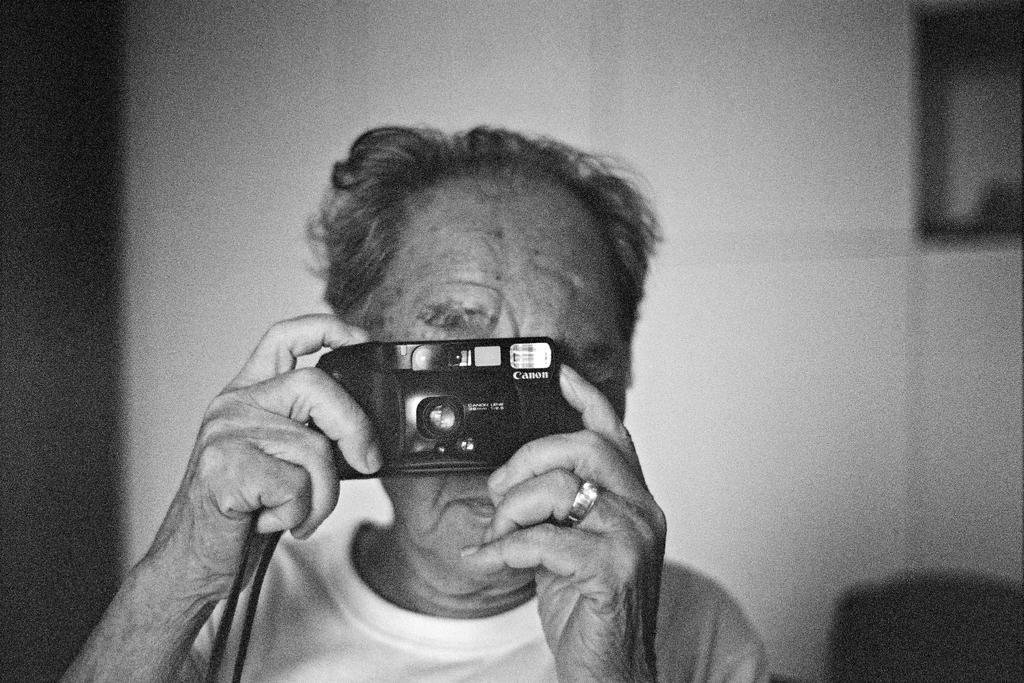In one or two sentences, can you explain what this image depicts? In the middle of the image a man is holding a camera, Behind him there is a wall. 